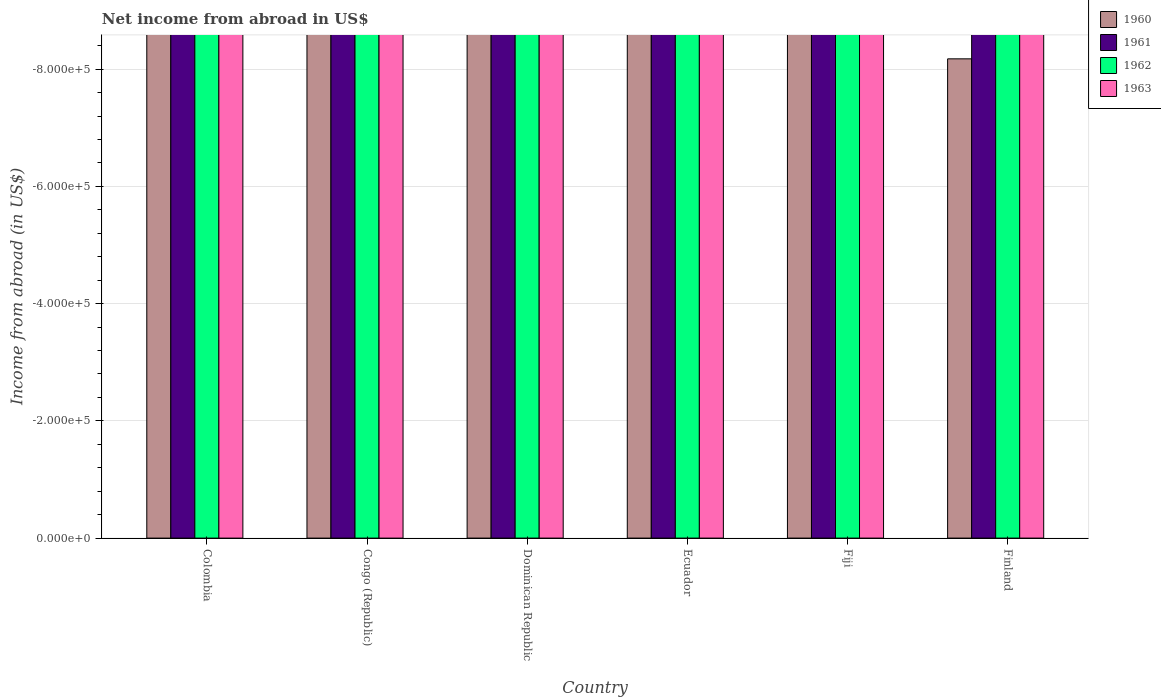How many different coloured bars are there?
Give a very brief answer. 0. Are the number of bars per tick equal to the number of legend labels?
Your answer should be compact. No. How many bars are there on the 3rd tick from the left?
Make the answer very short. 0. How many bars are there on the 2nd tick from the right?
Give a very brief answer. 0. What is the label of the 1st group of bars from the left?
Provide a short and direct response. Colombia. In how many cases, is the number of bars for a given country not equal to the number of legend labels?
Offer a very short reply. 6. Across all countries, what is the minimum net income from abroad in 1961?
Offer a terse response. 0. What is the total net income from abroad in 1960 in the graph?
Provide a succinct answer. 0. In how many countries, is the net income from abroad in 1960 greater than the average net income from abroad in 1960 taken over all countries?
Your answer should be compact. 0. Is it the case that in every country, the sum of the net income from abroad in 1960 and net income from abroad in 1961 is greater than the net income from abroad in 1963?
Keep it short and to the point. No. How many bars are there?
Keep it short and to the point. 0. How many countries are there in the graph?
Give a very brief answer. 6. Are the values on the major ticks of Y-axis written in scientific E-notation?
Offer a very short reply. Yes. Where does the legend appear in the graph?
Offer a very short reply. Top right. What is the title of the graph?
Give a very brief answer. Net income from abroad in US$. Does "1964" appear as one of the legend labels in the graph?
Offer a terse response. No. What is the label or title of the X-axis?
Provide a short and direct response. Country. What is the label or title of the Y-axis?
Offer a terse response. Income from abroad (in US$). What is the Income from abroad (in US$) in 1960 in Colombia?
Give a very brief answer. 0. What is the Income from abroad (in US$) in 1963 in Colombia?
Your answer should be very brief. 0. What is the Income from abroad (in US$) in 1961 in Congo (Republic)?
Ensure brevity in your answer.  0. What is the Income from abroad (in US$) in 1962 in Congo (Republic)?
Give a very brief answer. 0. What is the Income from abroad (in US$) of 1960 in Dominican Republic?
Your response must be concise. 0. What is the Income from abroad (in US$) in 1961 in Dominican Republic?
Offer a terse response. 0. What is the Income from abroad (in US$) in 1960 in Ecuador?
Your response must be concise. 0. What is the Income from abroad (in US$) of 1962 in Ecuador?
Ensure brevity in your answer.  0. What is the Income from abroad (in US$) of 1963 in Ecuador?
Provide a short and direct response. 0. What is the Income from abroad (in US$) in 1960 in Fiji?
Offer a very short reply. 0. What is the Income from abroad (in US$) of 1963 in Fiji?
Your answer should be very brief. 0. What is the Income from abroad (in US$) in 1961 in Finland?
Give a very brief answer. 0. What is the Income from abroad (in US$) in 1962 in Finland?
Keep it short and to the point. 0. What is the total Income from abroad (in US$) of 1961 in the graph?
Give a very brief answer. 0. What is the average Income from abroad (in US$) in 1960 per country?
Keep it short and to the point. 0. What is the average Income from abroad (in US$) of 1961 per country?
Your response must be concise. 0. What is the average Income from abroad (in US$) of 1962 per country?
Your answer should be very brief. 0. What is the average Income from abroad (in US$) in 1963 per country?
Offer a terse response. 0. 